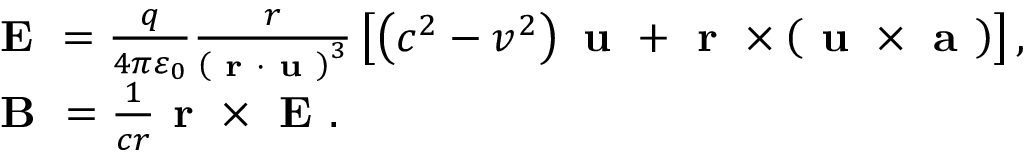Convert formula to latex. <formula><loc_0><loc_0><loc_500><loc_500>\begin{array} { r l } & { E = \frac { q } { 4 \pi \varepsilon _ { 0 } } \frac { r } { \left ( r \cdot u \right ) ^ { 3 } } \left [ \left ( c ^ { 2 } - v ^ { 2 } \right ) u + r \times \left ( u \times a \right ) \right ] , } \\ & { B = \frac { 1 } { c r } r \times E . } \end{array}</formula> 